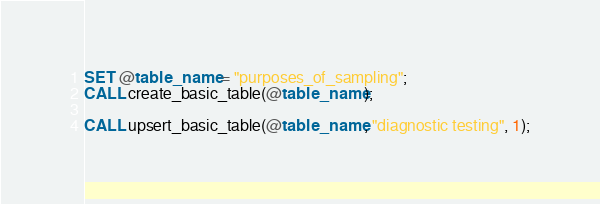<code> <loc_0><loc_0><loc_500><loc_500><_SQL_>SET @table_name = "purposes_of_sampling";
CALL create_basic_table(@table_name);

CALL upsert_basic_table(@table_name, "diagnostic testing", 1);
</code> 